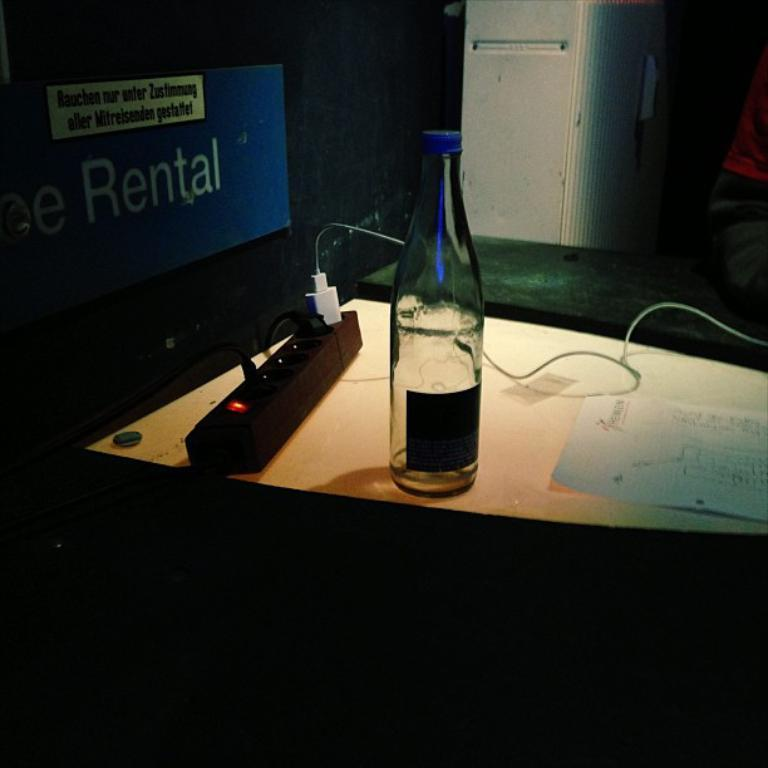Provide a one-sentence caption for the provided image. A sign that says rental is behind a power strip. 